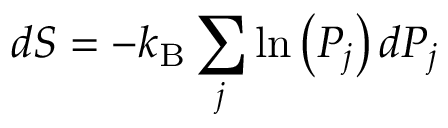<formula> <loc_0><loc_0><loc_500><loc_500>d S = - k _ { B } \sum _ { j } \ln \left ( P _ { j } \right ) d P _ { j }</formula> 